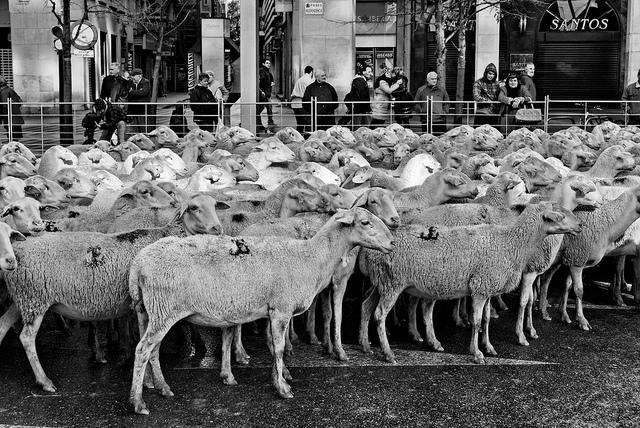How many people can be seen?
Quick response, please. 15. What type of animal is shown?
Short answer required. Sheep. Is the photo colored?
Concise answer only. No. 